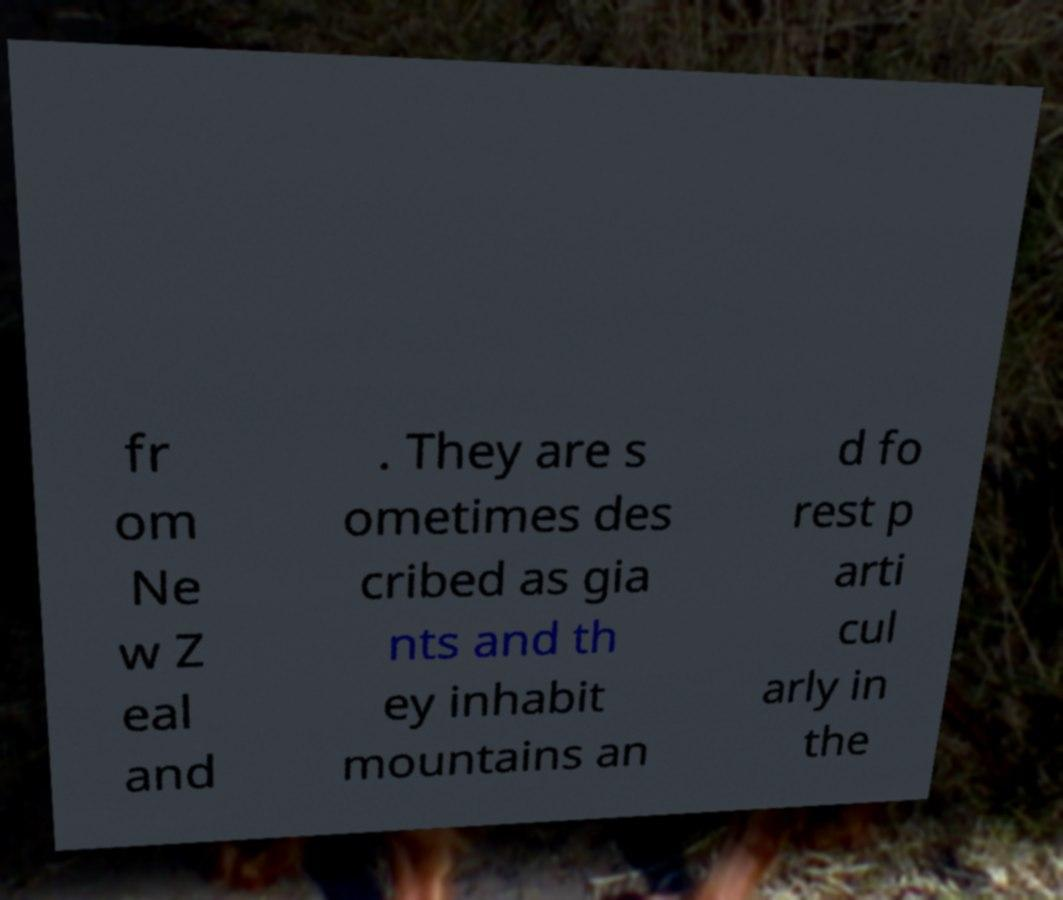Could you assist in decoding the text presented in this image and type it out clearly? fr om Ne w Z eal and . They are s ometimes des cribed as gia nts and th ey inhabit mountains an d fo rest p arti cul arly in the 